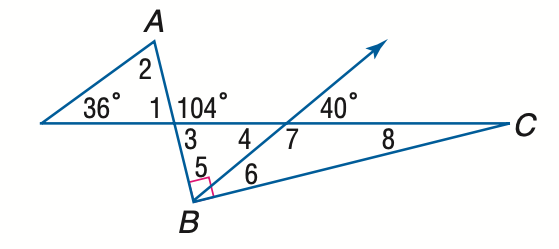Answer the mathemtical geometry problem and directly provide the correct option letter.
Question: Find the measure of \angle 7 if A B \perp B C.
Choices: A: 110 B: 120 C: 130 D: 140 D 